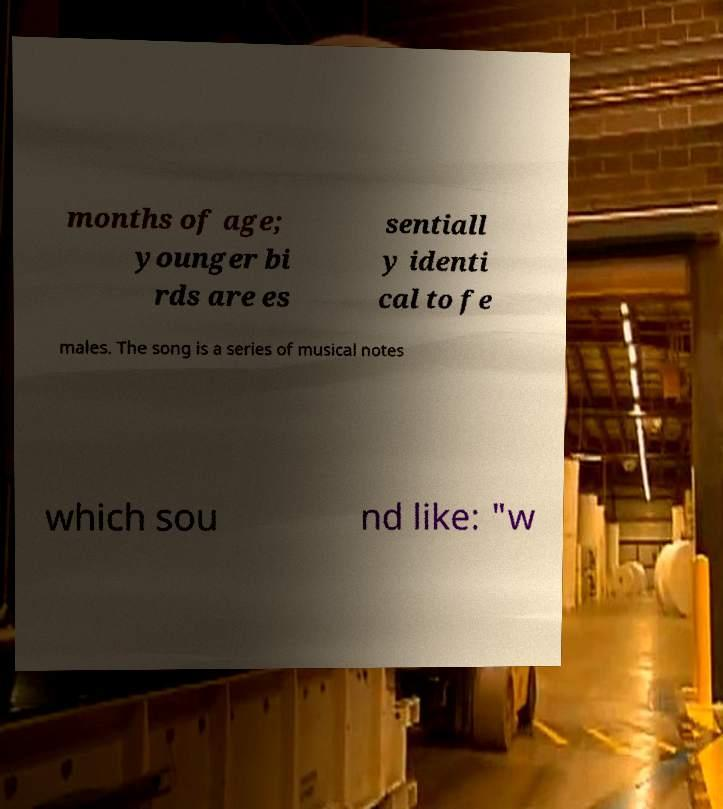Can you read and provide the text displayed in the image?This photo seems to have some interesting text. Can you extract and type it out for me? months of age; younger bi rds are es sentiall y identi cal to fe males. The song is a series of musical notes which sou nd like: "w 